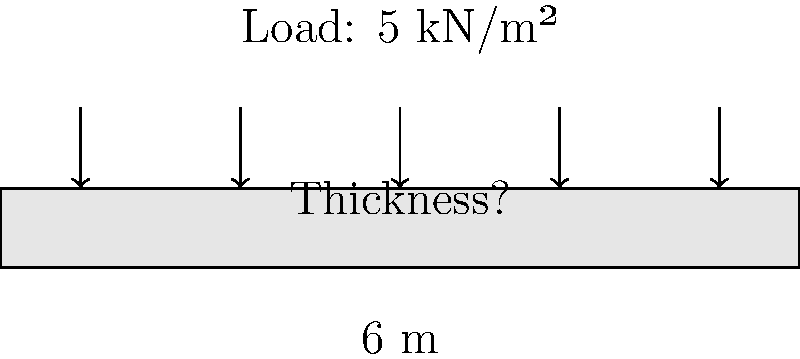For a small community center project, you need to calculate the required thickness of a concrete slab. The slab spans 6 meters and is expected to support a uniformly distributed load of 5 kN/m². Assuming a concrete strength of $f'_c = 25$ MPa and a steel yield strength of $f_y = 420$ MPa, determine the minimum thickness of the slab to the nearest centimeter. To determine the minimum thickness of the concrete slab, we'll follow these steps:

1. Estimate the slab thickness using the span-to-depth ratio method:
   For a simply supported slab, the ratio is typically 20 to 30.
   Let's use 25 as our ratio.
   Estimated thickness = Span / Ratio = $6 \text{ m} / 25 = 0.24 \text{ m}$

2. Calculate the self-weight of the slab:
   Assume concrete density = 24 kN/m³
   Self-weight = $0.24 \text{ m} \times 24 \text{ kN/m³} = 5.76 \text{ kN/m²}$

3. Calculate the total design load:
   Total load = Imposed load + Self-weight
   $= 5 \text{ kN/m²} + 5.76 \text{ kN/m²} = 10.76 \text{ kN/m²}$

4. Calculate the bending moment:
   $M = \frac{wL^2}{8}$, where $w$ is the total load per meter width
   $w = 10.76 \text{ kN/m²} \times 1 \text{ m} = 10.76 \text{ kN/m}$
   $M = \frac{10.76 \text{ kN/m} \times (6 \text{ m})^2}{8} = 48.42 \text{ kNm}$

5. Calculate the required effective depth using the moment capacity equation:
   $M = 0.15f'_cbd^2$
   $48.42 \times 10^6 = 0.15 \times 25 \times 1000 \times d^2$
   $d = \sqrt{\frac{48.42 \times 10^6}{0.15 \times 25 \times 1000}} = 203.4 \text{ mm}$

6. Add cover for reinforcement (assume 20 mm) and round up to the nearest centimeter:
   Total thickness = $203.4 \text{ mm} + 20 \text{ mm} = 223.4 \text{ mm} \approx 23 \text{ cm}$

Therefore, the minimum thickness of the slab should be 23 cm.
Answer: 23 cm 